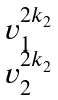<formula> <loc_0><loc_0><loc_500><loc_500>\begin{matrix} v _ { 1 } ^ { 2 k _ { 2 } } \\ v _ { 2 } ^ { 2 k _ { 2 } } \end{matrix}</formula> 